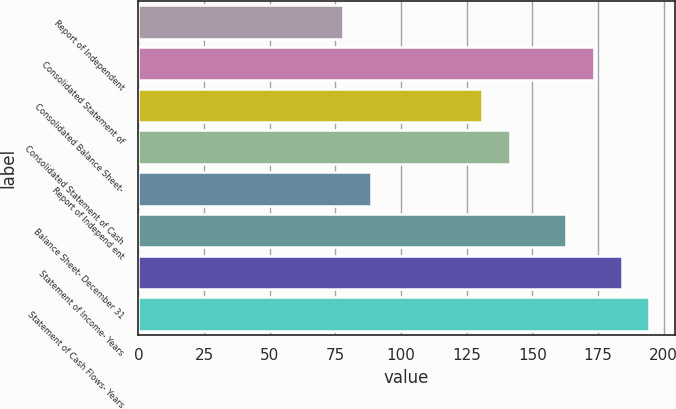Convert chart. <chart><loc_0><loc_0><loc_500><loc_500><bar_chart><fcel>Report of Independent<fcel>Consolidated Statement of<fcel>Consolidated Balance Sheet-<fcel>Consolidated Statement of Cash<fcel>Report of Independ ent<fcel>Balance Sheet- December 31<fcel>Statement of Income- Years<fcel>Statement of Cash Flows- Years<nl><fcel>78<fcel>173.4<fcel>131<fcel>141.6<fcel>88.6<fcel>162.8<fcel>184<fcel>194.6<nl></chart> 